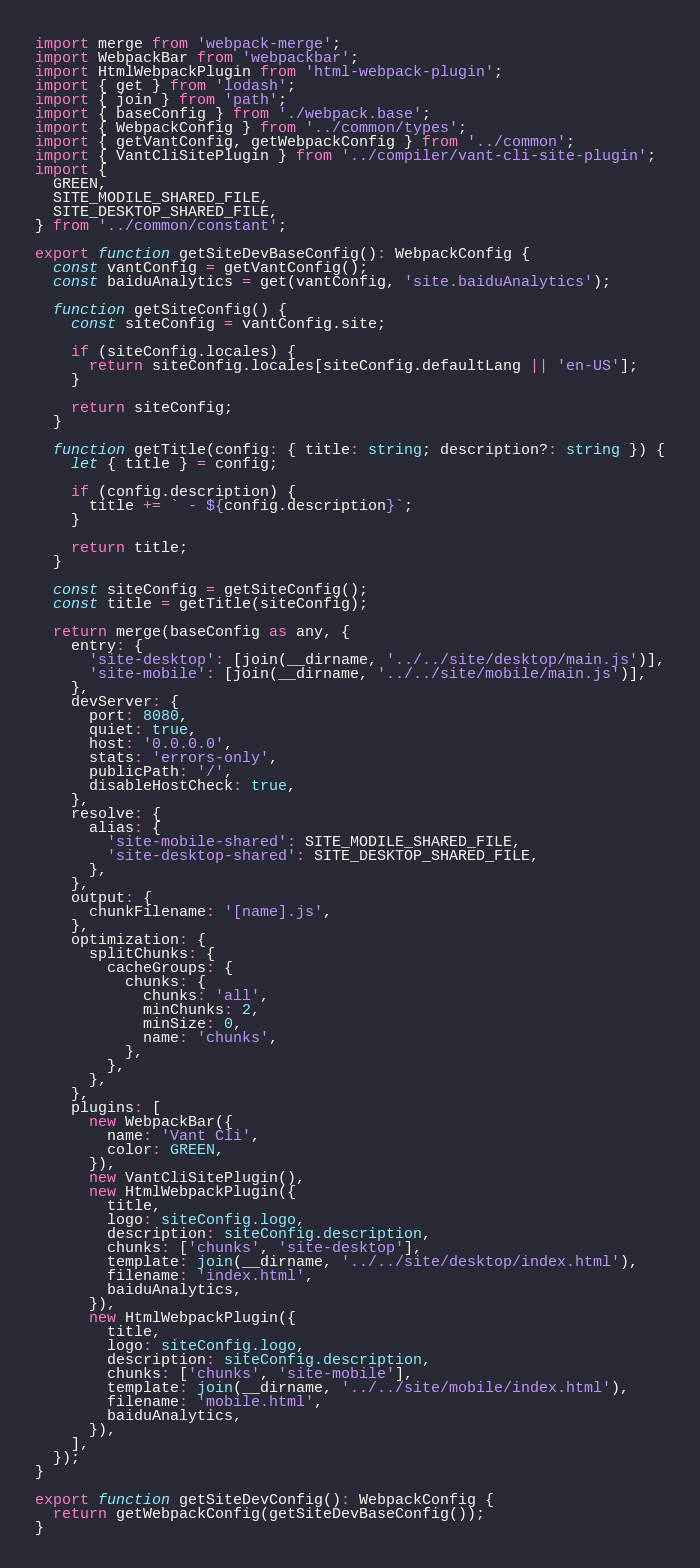Convert code to text. <code><loc_0><loc_0><loc_500><loc_500><_TypeScript_>import merge from 'webpack-merge';
import WebpackBar from 'webpackbar';
import HtmlWebpackPlugin from 'html-webpack-plugin';
import { get } from 'lodash';
import { join } from 'path';
import { baseConfig } from './webpack.base';
import { WebpackConfig } from '../common/types';
import { getVantConfig, getWebpackConfig } from '../common';
import { VantCliSitePlugin } from '../compiler/vant-cli-site-plugin';
import {
  GREEN,
  SITE_MODILE_SHARED_FILE,
  SITE_DESKTOP_SHARED_FILE,
} from '../common/constant';

export function getSiteDevBaseConfig(): WebpackConfig {
  const vantConfig = getVantConfig();
  const baiduAnalytics = get(vantConfig, 'site.baiduAnalytics');

  function getSiteConfig() {
    const siteConfig = vantConfig.site;

    if (siteConfig.locales) {
      return siteConfig.locales[siteConfig.defaultLang || 'en-US'];
    }

    return siteConfig;
  }

  function getTitle(config: { title: string; description?: string }) {
    let { title } = config;

    if (config.description) {
      title += ` - ${config.description}`;
    }

    return title;
  }

  const siteConfig = getSiteConfig();
  const title = getTitle(siteConfig);

  return merge(baseConfig as any, {
    entry: {
      'site-desktop': [join(__dirname, '../../site/desktop/main.js')],
      'site-mobile': [join(__dirname, '../../site/mobile/main.js')],
    },
    devServer: {
      port: 8080,
      quiet: true,
      host: '0.0.0.0',
      stats: 'errors-only',
      publicPath: '/',
      disableHostCheck: true,
    },
    resolve: {
      alias: {
        'site-mobile-shared': SITE_MODILE_SHARED_FILE,
        'site-desktop-shared': SITE_DESKTOP_SHARED_FILE,
      },
    },
    output: {
      chunkFilename: '[name].js',
    },
    optimization: {
      splitChunks: {
        cacheGroups: {
          chunks: {
            chunks: 'all',
            minChunks: 2,
            minSize: 0,
            name: 'chunks',
          },
        },
      },
    },
    plugins: [
      new WebpackBar({
        name: 'Vant Cli',
        color: GREEN,
      }),
      new VantCliSitePlugin(),
      new HtmlWebpackPlugin({
        title,
        logo: siteConfig.logo,
        description: siteConfig.description,
        chunks: ['chunks', 'site-desktop'],
        template: join(__dirname, '../../site/desktop/index.html'),
        filename: 'index.html',
        baiduAnalytics,
      }),
      new HtmlWebpackPlugin({
        title,
        logo: siteConfig.logo,
        description: siteConfig.description,
        chunks: ['chunks', 'site-mobile'],
        template: join(__dirname, '../../site/mobile/index.html'),
        filename: 'mobile.html',
        baiduAnalytics,
      }),
    ],
  });
}

export function getSiteDevConfig(): WebpackConfig {
  return getWebpackConfig(getSiteDevBaseConfig());
}
</code> 